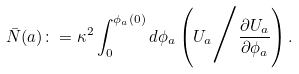Convert formula to latex. <formula><loc_0><loc_0><loc_500><loc_500>\bar { N } ( a ) \colon = \kappa ^ { 2 } \int ^ { \phi _ { a } ( 0 ) } _ { 0 } d \phi _ { a } \left ( U _ { a } \Big / \frac { \partial U _ { a } } { \partial \phi _ { a } } \right ) .</formula> 